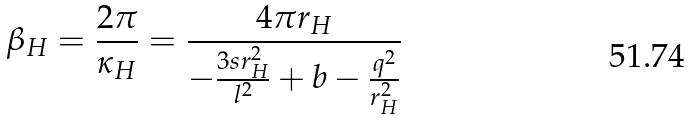Convert formula to latex. <formula><loc_0><loc_0><loc_500><loc_500>\beta _ { H } = \frac { 2 \pi } { \kappa _ { H } } = \frac { 4 \pi r _ { H } } { - \frac { 3 s r ^ { 2 } _ { H } } { l ^ { 2 } } + { b } - \frac { q ^ { 2 } } { r ^ { 2 } _ { H } } }</formula> 